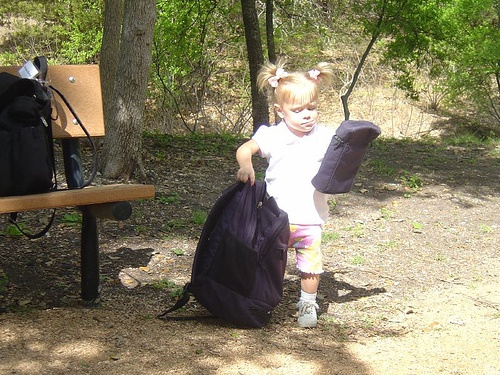Describe the objects in this image and their specific colors. I can see people in olive, white, tan, and darkgray tones, backpack in olive, black, and gray tones, bench in olive, black, brown, gray, and tan tones, handbag in olive, black, gray, and tan tones, and backpack in olive, black, gray, and lightgray tones in this image. 